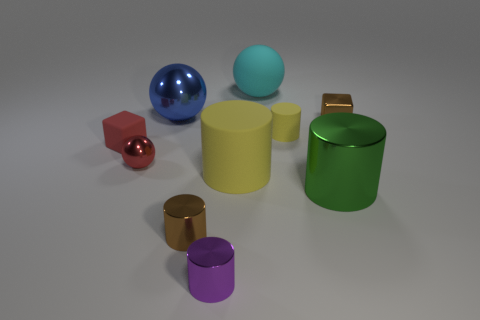Subtract 3 cylinders. How many cylinders are left? 2 Subtract all metallic balls. How many balls are left? 1 Subtract all yellow cylinders. How many cylinders are left? 3 Subtract all green cylinders. Subtract all red blocks. How many cylinders are left? 4 Subtract all spheres. How many objects are left? 7 Add 10 blue rubber cylinders. How many blue rubber cylinders exist? 10 Subtract 0 cyan cubes. How many objects are left? 10 Subtract all cubes. Subtract all red shiny spheres. How many objects are left? 7 Add 8 small brown cylinders. How many small brown cylinders are left? 9 